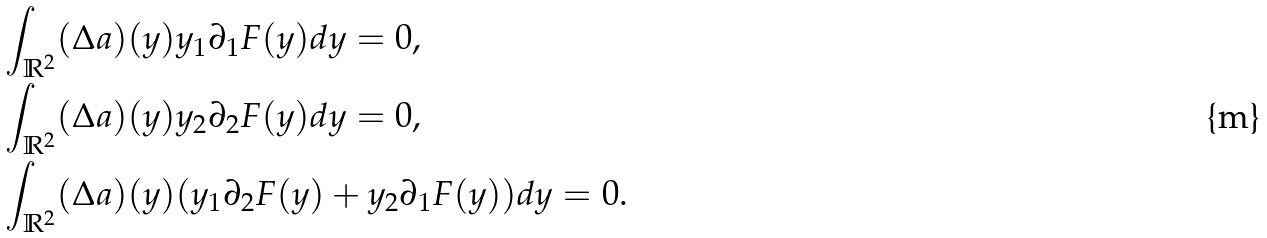<formula> <loc_0><loc_0><loc_500><loc_500>& \int _ { \mathbb { R } ^ { 2 } } ( \Delta a ) ( y ) y _ { 1 } \partial _ { 1 } F ( y ) d y = 0 , \\ & \int _ { \mathbb { R } ^ { 2 } } ( \Delta a ) ( y ) y _ { 2 } \partial _ { 2 } F ( y ) d y = 0 , \\ & \int _ { \mathbb { R } ^ { 2 } } ( \Delta a ) ( y ) ( y _ { 1 } \partial _ { 2 } F ( y ) + y _ { 2 } \partial _ { 1 } F ( y ) ) d y = 0 .</formula> 